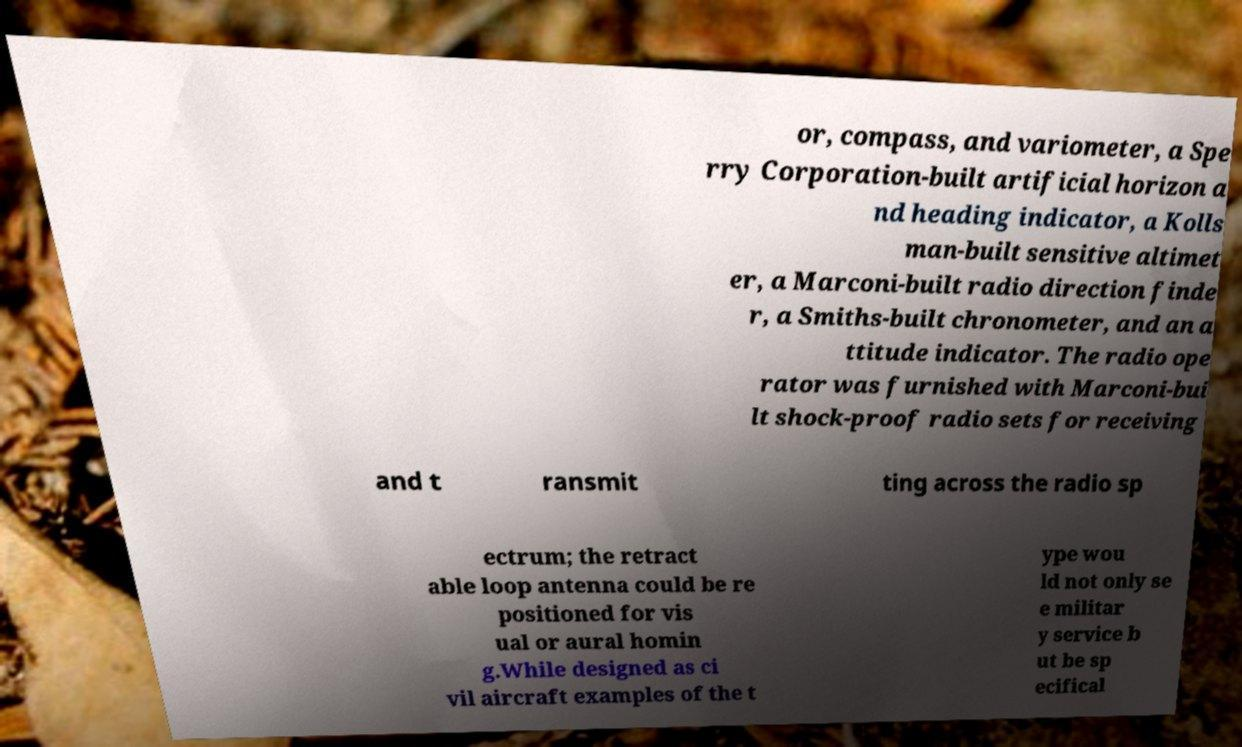Can you read and provide the text displayed in the image?This photo seems to have some interesting text. Can you extract and type it out for me? or, compass, and variometer, a Spe rry Corporation-built artificial horizon a nd heading indicator, a Kolls man-built sensitive altimet er, a Marconi-built radio direction finde r, a Smiths-built chronometer, and an a ttitude indicator. The radio ope rator was furnished with Marconi-bui lt shock-proof radio sets for receiving and t ransmit ting across the radio sp ectrum; the retract able loop antenna could be re positioned for vis ual or aural homin g.While designed as ci vil aircraft examples of the t ype wou ld not only se e militar y service b ut be sp ecifical 